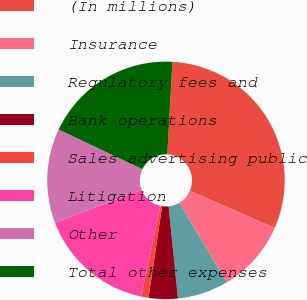<chart> <loc_0><loc_0><loc_500><loc_500><pie_chart><fcel>(In millions)<fcel>Insurance<fcel>Regulatory fees and<fcel>Bank operations<fcel>Sales advertising public<fcel>Litigation<fcel>Other<fcel>Total other expenses<nl><fcel>30.69%<fcel>9.9%<fcel>6.93%<fcel>3.96%<fcel>0.99%<fcel>15.84%<fcel>12.87%<fcel>18.81%<nl></chart> 